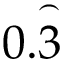<formula> <loc_0><loc_0><loc_500><loc_500>0 . { \overset { \frown } { 3 } }</formula> 